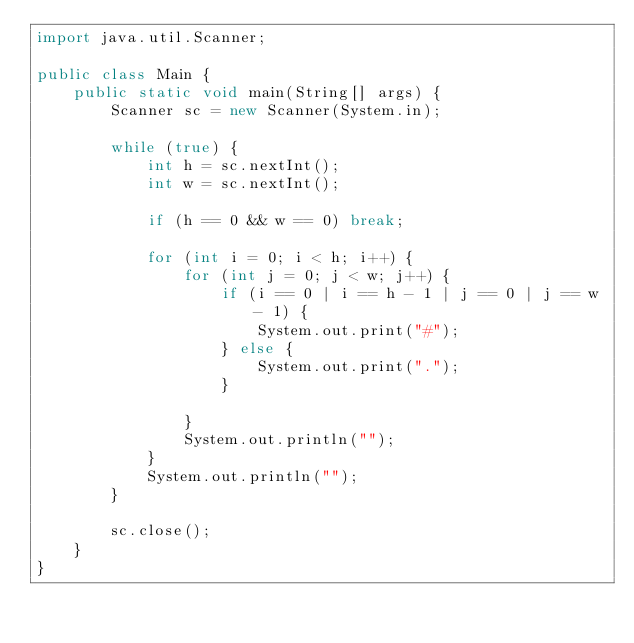Convert code to text. <code><loc_0><loc_0><loc_500><loc_500><_Java_>import java.util.Scanner;

public class Main {
    public static void main(String[] args) {
        Scanner sc = new Scanner(System.in);

        while (true) {
            int h = sc.nextInt();
            int w = sc.nextInt();

            if (h == 0 && w == 0) break;

            for (int i = 0; i < h; i++) {
                for (int j = 0; j < w; j++) {
                    if (i == 0 | i == h - 1 | j == 0 | j == w - 1) {
                        System.out.print("#");
                    } else {
                        System.out.print(".");
                    }

                }
                System.out.println("");
            }
            System.out.println("");
        }

        sc.close();
    }
}
</code> 